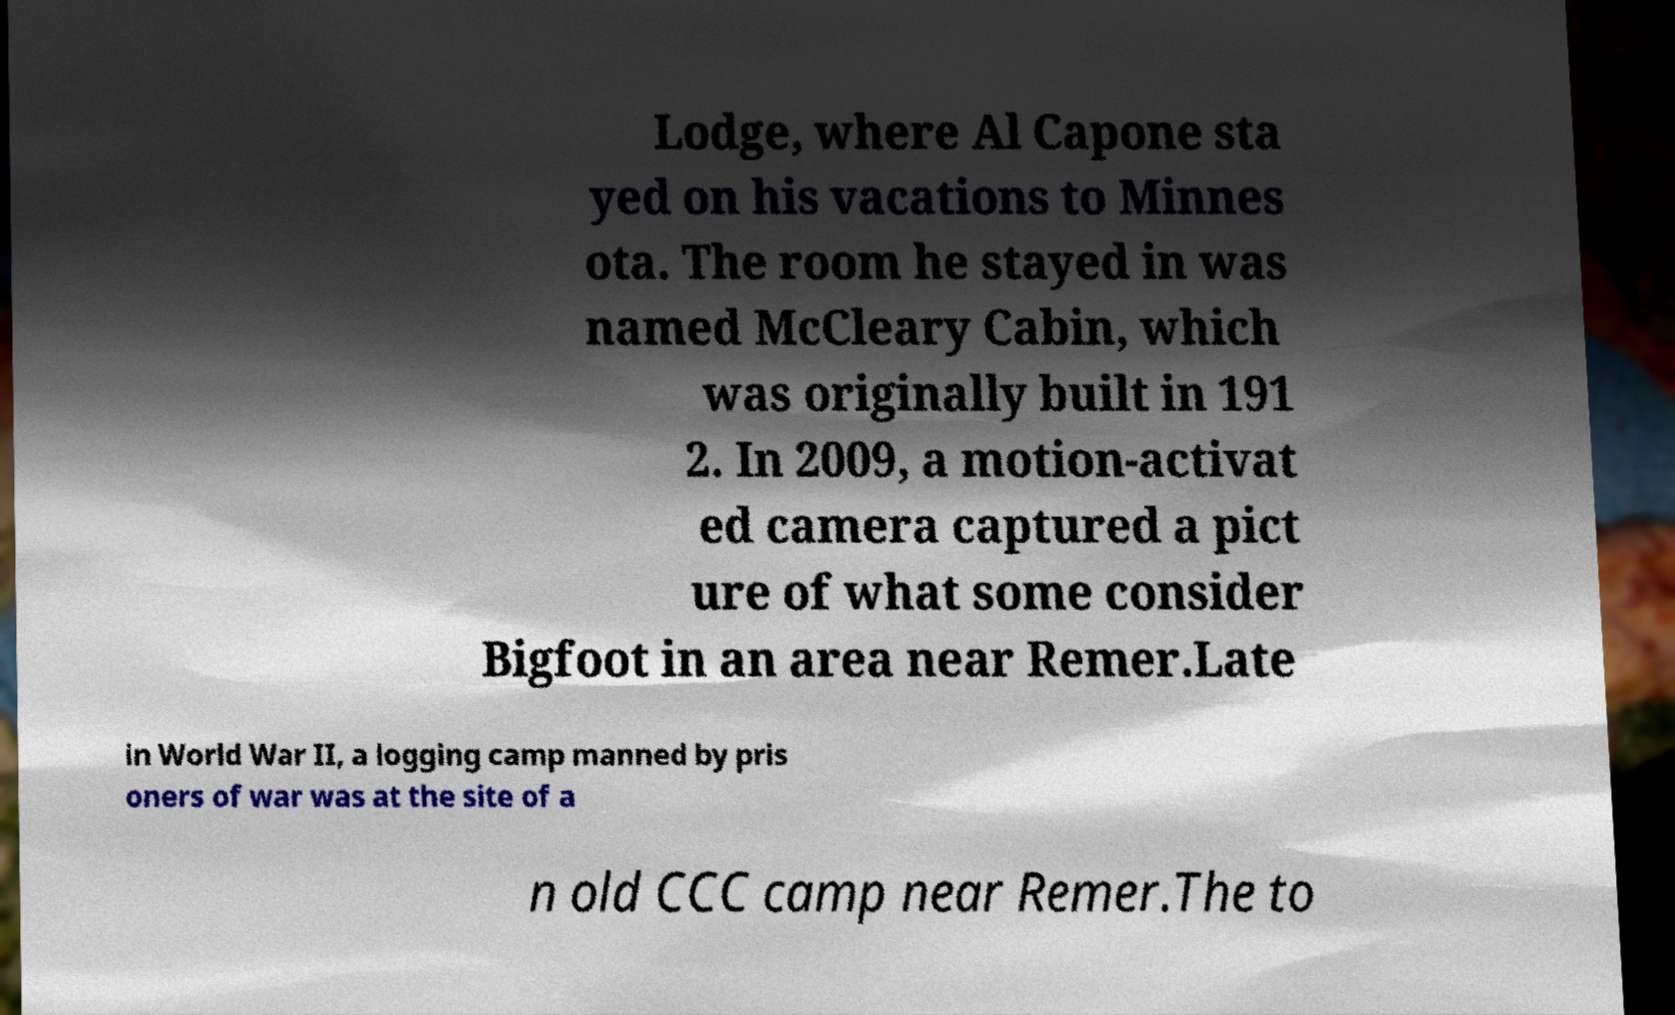Please identify and transcribe the text found in this image. Lodge, where Al Capone sta yed on his vacations to Minnes ota. The room he stayed in was named McCleary Cabin, which was originally built in 191 2. In 2009, a motion-activat ed camera captured a pict ure of what some consider Bigfoot in an area near Remer.Late in World War II, a logging camp manned by pris oners of war was at the site of a n old CCC camp near Remer.The to 